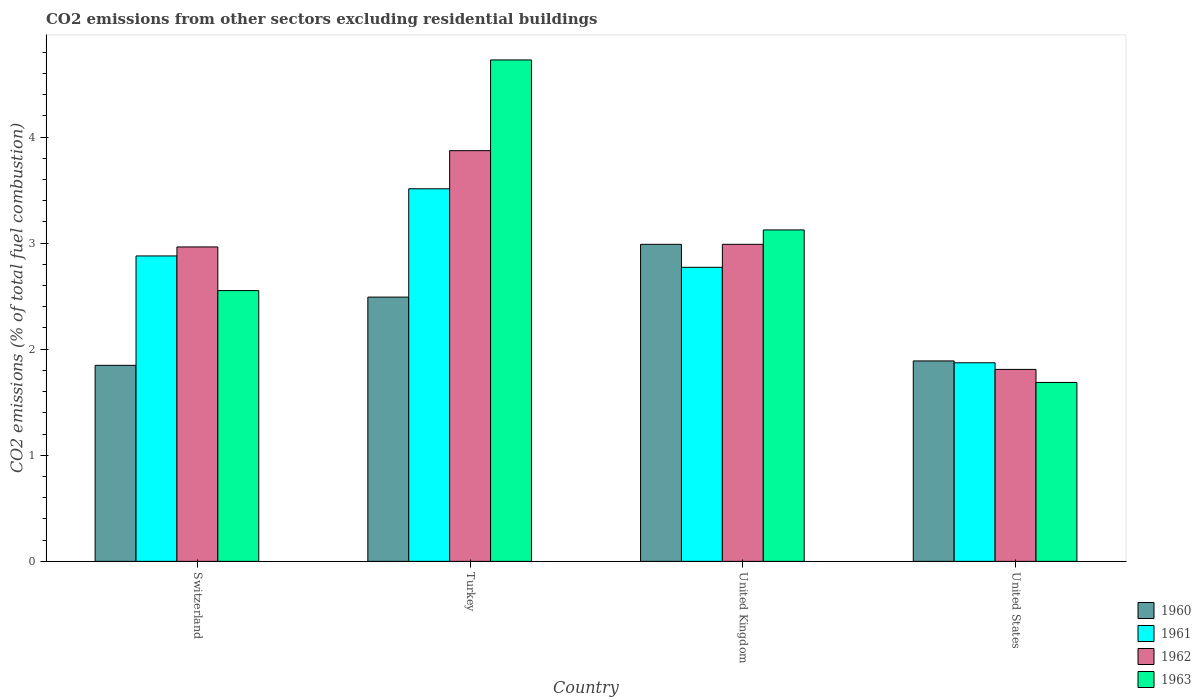How many different coloured bars are there?
Your response must be concise. 4. How many groups of bars are there?
Keep it short and to the point. 4. Are the number of bars per tick equal to the number of legend labels?
Ensure brevity in your answer.  Yes. Are the number of bars on each tick of the X-axis equal?
Keep it short and to the point. Yes. What is the label of the 2nd group of bars from the left?
Make the answer very short. Turkey. In how many cases, is the number of bars for a given country not equal to the number of legend labels?
Provide a short and direct response. 0. What is the total CO2 emitted in 1961 in Turkey?
Provide a short and direct response. 3.51. Across all countries, what is the maximum total CO2 emitted in 1963?
Your response must be concise. 4.73. Across all countries, what is the minimum total CO2 emitted in 1960?
Your answer should be compact. 1.85. In which country was the total CO2 emitted in 1961 maximum?
Keep it short and to the point. Turkey. In which country was the total CO2 emitted in 1962 minimum?
Ensure brevity in your answer.  United States. What is the total total CO2 emitted in 1961 in the graph?
Provide a succinct answer. 11.03. What is the difference between the total CO2 emitted in 1961 in Turkey and that in United Kingdom?
Provide a succinct answer. 0.74. What is the difference between the total CO2 emitted in 1960 in Turkey and the total CO2 emitted in 1963 in United Kingdom?
Offer a very short reply. -0.63. What is the average total CO2 emitted in 1963 per country?
Keep it short and to the point. 3.02. What is the difference between the total CO2 emitted of/in 1963 and total CO2 emitted of/in 1961 in United Kingdom?
Offer a very short reply. 0.35. In how many countries, is the total CO2 emitted in 1960 greater than 1.4?
Keep it short and to the point. 4. What is the ratio of the total CO2 emitted in 1961 in United Kingdom to that in United States?
Give a very brief answer. 1.48. Is the difference between the total CO2 emitted in 1963 in Turkey and United States greater than the difference between the total CO2 emitted in 1961 in Turkey and United States?
Make the answer very short. Yes. What is the difference between the highest and the second highest total CO2 emitted in 1961?
Your response must be concise. -0.63. What is the difference between the highest and the lowest total CO2 emitted in 1960?
Your answer should be compact. 1.14. Is it the case that in every country, the sum of the total CO2 emitted in 1960 and total CO2 emitted in 1961 is greater than the sum of total CO2 emitted in 1963 and total CO2 emitted in 1962?
Keep it short and to the point. No. What does the 1st bar from the left in United Kingdom represents?
Your answer should be very brief. 1960. Is it the case that in every country, the sum of the total CO2 emitted in 1963 and total CO2 emitted in 1962 is greater than the total CO2 emitted in 1961?
Provide a succinct answer. Yes. Are all the bars in the graph horizontal?
Give a very brief answer. No. How many countries are there in the graph?
Provide a succinct answer. 4. Are the values on the major ticks of Y-axis written in scientific E-notation?
Offer a terse response. No. Does the graph contain any zero values?
Make the answer very short. No. Where does the legend appear in the graph?
Your response must be concise. Bottom right. How many legend labels are there?
Offer a very short reply. 4. What is the title of the graph?
Your answer should be compact. CO2 emissions from other sectors excluding residential buildings. What is the label or title of the Y-axis?
Ensure brevity in your answer.  CO2 emissions (% of total fuel combustion). What is the CO2 emissions (% of total fuel combustion) of 1960 in Switzerland?
Make the answer very short. 1.85. What is the CO2 emissions (% of total fuel combustion) of 1961 in Switzerland?
Make the answer very short. 2.88. What is the CO2 emissions (% of total fuel combustion) of 1962 in Switzerland?
Make the answer very short. 2.96. What is the CO2 emissions (% of total fuel combustion) in 1963 in Switzerland?
Give a very brief answer. 2.55. What is the CO2 emissions (% of total fuel combustion) in 1960 in Turkey?
Offer a very short reply. 2.49. What is the CO2 emissions (% of total fuel combustion) in 1961 in Turkey?
Offer a very short reply. 3.51. What is the CO2 emissions (% of total fuel combustion) in 1962 in Turkey?
Your response must be concise. 3.87. What is the CO2 emissions (% of total fuel combustion) in 1963 in Turkey?
Ensure brevity in your answer.  4.73. What is the CO2 emissions (% of total fuel combustion) in 1960 in United Kingdom?
Ensure brevity in your answer.  2.99. What is the CO2 emissions (% of total fuel combustion) of 1961 in United Kingdom?
Keep it short and to the point. 2.77. What is the CO2 emissions (% of total fuel combustion) of 1962 in United Kingdom?
Make the answer very short. 2.99. What is the CO2 emissions (% of total fuel combustion) in 1963 in United Kingdom?
Ensure brevity in your answer.  3.12. What is the CO2 emissions (% of total fuel combustion) in 1960 in United States?
Your answer should be very brief. 1.89. What is the CO2 emissions (% of total fuel combustion) of 1961 in United States?
Keep it short and to the point. 1.87. What is the CO2 emissions (% of total fuel combustion) of 1962 in United States?
Your response must be concise. 1.81. What is the CO2 emissions (% of total fuel combustion) in 1963 in United States?
Offer a very short reply. 1.69. Across all countries, what is the maximum CO2 emissions (% of total fuel combustion) of 1960?
Ensure brevity in your answer.  2.99. Across all countries, what is the maximum CO2 emissions (% of total fuel combustion) of 1961?
Make the answer very short. 3.51. Across all countries, what is the maximum CO2 emissions (% of total fuel combustion) of 1962?
Keep it short and to the point. 3.87. Across all countries, what is the maximum CO2 emissions (% of total fuel combustion) in 1963?
Offer a very short reply. 4.73. Across all countries, what is the minimum CO2 emissions (% of total fuel combustion) in 1960?
Ensure brevity in your answer.  1.85. Across all countries, what is the minimum CO2 emissions (% of total fuel combustion) of 1961?
Provide a succinct answer. 1.87. Across all countries, what is the minimum CO2 emissions (% of total fuel combustion) in 1962?
Your answer should be compact. 1.81. Across all countries, what is the minimum CO2 emissions (% of total fuel combustion) in 1963?
Keep it short and to the point. 1.69. What is the total CO2 emissions (% of total fuel combustion) in 1960 in the graph?
Give a very brief answer. 9.22. What is the total CO2 emissions (% of total fuel combustion) in 1961 in the graph?
Make the answer very short. 11.03. What is the total CO2 emissions (% of total fuel combustion) in 1962 in the graph?
Offer a very short reply. 11.63. What is the total CO2 emissions (% of total fuel combustion) of 1963 in the graph?
Make the answer very short. 12.09. What is the difference between the CO2 emissions (% of total fuel combustion) of 1960 in Switzerland and that in Turkey?
Make the answer very short. -0.64. What is the difference between the CO2 emissions (% of total fuel combustion) in 1961 in Switzerland and that in Turkey?
Provide a succinct answer. -0.63. What is the difference between the CO2 emissions (% of total fuel combustion) of 1962 in Switzerland and that in Turkey?
Provide a short and direct response. -0.91. What is the difference between the CO2 emissions (% of total fuel combustion) of 1963 in Switzerland and that in Turkey?
Ensure brevity in your answer.  -2.17. What is the difference between the CO2 emissions (% of total fuel combustion) in 1960 in Switzerland and that in United Kingdom?
Keep it short and to the point. -1.14. What is the difference between the CO2 emissions (% of total fuel combustion) of 1961 in Switzerland and that in United Kingdom?
Your answer should be compact. 0.11. What is the difference between the CO2 emissions (% of total fuel combustion) in 1962 in Switzerland and that in United Kingdom?
Give a very brief answer. -0.02. What is the difference between the CO2 emissions (% of total fuel combustion) of 1963 in Switzerland and that in United Kingdom?
Give a very brief answer. -0.57. What is the difference between the CO2 emissions (% of total fuel combustion) of 1960 in Switzerland and that in United States?
Offer a very short reply. -0.04. What is the difference between the CO2 emissions (% of total fuel combustion) in 1961 in Switzerland and that in United States?
Provide a succinct answer. 1.01. What is the difference between the CO2 emissions (% of total fuel combustion) in 1962 in Switzerland and that in United States?
Offer a terse response. 1.15. What is the difference between the CO2 emissions (% of total fuel combustion) of 1963 in Switzerland and that in United States?
Provide a succinct answer. 0.87. What is the difference between the CO2 emissions (% of total fuel combustion) of 1960 in Turkey and that in United Kingdom?
Provide a succinct answer. -0.5. What is the difference between the CO2 emissions (% of total fuel combustion) of 1961 in Turkey and that in United Kingdom?
Provide a short and direct response. 0.74. What is the difference between the CO2 emissions (% of total fuel combustion) in 1962 in Turkey and that in United Kingdom?
Offer a terse response. 0.88. What is the difference between the CO2 emissions (% of total fuel combustion) in 1963 in Turkey and that in United Kingdom?
Your answer should be very brief. 1.6. What is the difference between the CO2 emissions (% of total fuel combustion) in 1960 in Turkey and that in United States?
Offer a terse response. 0.6. What is the difference between the CO2 emissions (% of total fuel combustion) in 1961 in Turkey and that in United States?
Make the answer very short. 1.64. What is the difference between the CO2 emissions (% of total fuel combustion) in 1962 in Turkey and that in United States?
Your response must be concise. 2.06. What is the difference between the CO2 emissions (% of total fuel combustion) of 1963 in Turkey and that in United States?
Make the answer very short. 3.04. What is the difference between the CO2 emissions (% of total fuel combustion) in 1960 in United Kingdom and that in United States?
Your response must be concise. 1.1. What is the difference between the CO2 emissions (% of total fuel combustion) of 1961 in United Kingdom and that in United States?
Your answer should be very brief. 0.9. What is the difference between the CO2 emissions (% of total fuel combustion) of 1962 in United Kingdom and that in United States?
Make the answer very short. 1.18. What is the difference between the CO2 emissions (% of total fuel combustion) in 1963 in United Kingdom and that in United States?
Your response must be concise. 1.44. What is the difference between the CO2 emissions (% of total fuel combustion) in 1960 in Switzerland and the CO2 emissions (% of total fuel combustion) in 1961 in Turkey?
Provide a short and direct response. -1.66. What is the difference between the CO2 emissions (% of total fuel combustion) of 1960 in Switzerland and the CO2 emissions (% of total fuel combustion) of 1962 in Turkey?
Offer a very short reply. -2.02. What is the difference between the CO2 emissions (% of total fuel combustion) of 1960 in Switzerland and the CO2 emissions (% of total fuel combustion) of 1963 in Turkey?
Your answer should be very brief. -2.88. What is the difference between the CO2 emissions (% of total fuel combustion) of 1961 in Switzerland and the CO2 emissions (% of total fuel combustion) of 1962 in Turkey?
Offer a terse response. -0.99. What is the difference between the CO2 emissions (% of total fuel combustion) of 1961 in Switzerland and the CO2 emissions (% of total fuel combustion) of 1963 in Turkey?
Provide a succinct answer. -1.85. What is the difference between the CO2 emissions (% of total fuel combustion) in 1962 in Switzerland and the CO2 emissions (% of total fuel combustion) in 1963 in Turkey?
Make the answer very short. -1.76. What is the difference between the CO2 emissions (% of total fuel combustion) of 1960 in Switzerland and the CO2 emissions (% of total fuel combustion) of 1961 in United Kingdom?
Provide a succinct answer. -0.92. What is the difference between the CO2 emissions (% of total fuel combustion) of 1960 in Switzerland and the CO2 emissions (% of total fuel combustion) of 1962 in United Kingdom?
Your response must be concise. -1.14. What is the difference between the CO2 emissions (% of total fuel combustion) in 1960 in Switzerland and the CO2 emissions (% of total fuel combustion) in 1963 in United Kingdom?
Your answer should be compact. -1.28. What is the difference between the CO2 emissions (% of total fuel combustion) of 1961 in Switzerland and the CO2 emissions (% of total fuel combustion) of 1962 in United Kingdom?
Keep it short and to the point. -0.11. What is the difference between the CO2 emissions (% of total fuel combustion) of 1961 in Switzerland and the CO2 emissions (% of total fuel combustion) of 1963 in United Kingdom?
Ensure brevity in your answer.  -0.25. What is the difference between the CO2 emissions (% of total fuel combustion) of 1962 in Switzerland and the CO2 emissions (% of total fuel combustion) of 1963 in United Kingdom?
Provide a succinct answer. -0.16. What is the difference between the CO2 emissions (% of total fuel combustion) of 1960 in Switzerland and the CO2 emissions (% of total fuel combustion) of 1961 in United States?
Offer a very short reply. -0.02. What is the difference between the CO2 emissions (% of total fuel combustion) of 1960 in Switzerland and the CO2 emissions (% of total fuel combustion) of 1962 in United States?
Offer a terse response. 0.04. What is the difference between the CO2 emissions (% of total fuel combustion) of 1960 in Switzerland and the CO2 emissions (% of total fuel combustion) of 1963 in United States?
Provide a short and direct response. 0.16. What is the difference between the CO2 emissions (% of total fuel combustion) in 1961 in Switzerland and the CO2 emissions (% of total fuel combustion) in 1962 in United States?
Provide a short and direct response. 1.07. What is the difference between the CO2 emissions (% of total fuel combustion) in 1961 in Switzerland and the CO2 emissions (% of total fuel combustion) in 1963 in United States?
Provide a succinct answer. 1.19. What is the difference between the CO2 emissions (% of total fuel combustion) in 1962 in Switzerland and the CO2 emissions (% of total fuel combustion) in 1963 in United States?
Give a very brief answer. 1.28. What is the difference between the CO2 emissions (% of total fuel combustion) of 1960 in Turkey and the CO2 emissions (% of total fuel combustion) of 1961 in United Kingdom?
Provide a succinct answer. -0.28. What is the difference between the CO2 emissions (% of total fuel combustion) of 1960 in Turkey and the CO2 emissions (% of total fuel combustion) of 1962 in United Kingdom?
Your answer should be very brief. -0.5. What is the difference between the CO2 emissions (% of total fuel combustion) of 1960 in Turkey and the CO2 emissions (% of total fuel combustion) of 1963 in United Kingdom?
Your response must be concise. -0.63. What is the difference between the CO2 emissions (% of total fuel combustion) of 1961 in Turkey and the CO2 emissions (% of total fuel combustion) of 1962 in United Kingdom?
Offer a terse response. 0.52. What is the difference between the CO2 emissions (% of total fuel combustion) in 1961 in Turkey and the CO2 emissions (% of total fuel combustion) in 1963 in United Kingdom?
Make the answer very short. 0.39. What is the difference between the CO2 emissions (% of total fuel combustion) in 1962 in Turkey and the CO2 emissions (% of total fuel combustion) in 1963 in United Kingdom?
Your answer should be compact. 0.75. What is the difference between the CO2 emissions (% of total fuel combustion) in 1960 in Turkey and the CO2 emissions (% of total fuel combustion) in 1961 in United States?
Your response must be concise. 0.62. What is the difference between the CO2 emissions (% of total fuel combustion) in 1960 in Turkey and the CO2 emissions (% of total fuel combustion) in 1962 in United States?
Make the answer very short. 0.68. What is the difference between the CO2 emissions (% of total fuel combustion) of 1960 in Turkey and the CO2 emissions (% of total fuel combustion) of 1963 in United States?
Ensure brevity in your answer.  0.8. What is the difference between the CO2 emissions (% of total fuel combustion) in 1961 in Turkey and the CO2 emissions (% of total fuel combustion) in 1962 in United States?
Make the answer very short. 1.7. What is the difference between the CO2 emissions (% of total fuel combustion) of 1961 in Turkey and the CO2 emissions (% of total fuel combustion) of 1963 in United States?
Your answer should be very brief. 1.83. What is the difference between the CO2 emissions (% of total fuel combustion) of 1962 in Turkey and the CO2 emissions (% of total fuel combustion) of 1963 in United States?
Give a very brief answer. 2.18. What is the difference between the CO2 emissions (% of total fuel combustion) of 1960 in United Kingdom and the CO2 emissions (% of total fuel combustion) of 1961 in United States?
Your response must be concise. 1.12. What is the difference between the CO2 emissions (% of total fuel combustion) of 1960 in United Kingdom and the CO2 emissions (% of total fuel combustion) of 1962 in United States?
Provide a short and direct response. 1.18. What is the difference between the CO2 emissions (% of total fuel combustion) in 1960 in United Kingdom and the CO2 emissions (% of total fuel combustion) in 1963 in United States?
Offer a terse response. 1.3. What is the difference between the CO2 emissions (% of total fuel combustion) in 1961 in United Kingdom and the CO2 emissions (% of total fuel combustion) in 1962 in United States?
Offer a very short reply. 0.96. What is the difference between the CO2 emissions (% of total fuel combustion) in 1961 in United Kingdom and the CO2 emissions (% of total fuel combustion) in 1963 in United States?
Your answer should be very brief. 1.09. What is the difference between the CO2 emissions (% of total fuel combustion) in 1962 in United Kingdom and the CO2 emissions (% of total fuel combustion) in 1963 in United States?
Your answer should be compact. 1.3. What is the average CO2 emissions (% of total fuel combustion) of 1960 per country?
Keep it short and to the point. 2.3. What is the average CO2 emissions (% of total fuel combustion) of 1961 per country?
Provide a succinct answer. 2.76. What is the average CO2 emissions (% of total fuel combustion) of 1962 per country?
Offer a very short reply. 2.91. What is the average CO2 emissions (% of total fuel combustion) in 1963 per country?
Provide a succinct answer. 3.02. What is the difference between the CO2 emissions (% of total fuel combustion) of 1960 and CO2 emissions (% of total fuel combustion) of 1961 in Switzerland?
Provide a short and direct response. -1.03. What is the difference between the CO2 emissions (% of total fuel combustion) in 1960 and CO2 emissions (% of total fuel combustion) in 1962 in Switzerland?
Make the answer very short. -1.12. What is the difference between the CO2 emissions (% of total fuel combustion) of 1960 and CO2 emissions (% of total fuel combustion) of 1963 in Switzerland?
Your answer should be compact. -0.7. What is the difference between the CO2 emissions (% of total fuel combustion) in 1961 and CO2 emissions (% of total fuel combustion) in 1962 in Switzerland?
Your response must be concise. -0.08. What is the difference between the CO2 emissions (% of total fuel combustion) in 1961 and CO2 emissions (% of total fuel combustion) in 1963 in Switzerland?
Your answer should be very brief. 0.33. What is the difference between the CO2 emissions (% of total fuel combustion) in 1962 and CO2 emissions (% of total fuel combustion) in 1963 in Switzerland?
Provide a succinct answer. 0.41. What is the difference between the CO2 emissions (% of total fuel combustion) in 1960 and CO2 emissions (% of total fuel combustion) in 1961 in Turkey?
Your answer should be compact. -1.02. What is the difference between the CO2 emissions (% of total fuel combustion) of 1960 and CO2 emissions (% of total fuel combustion) of 1962 in Turkey?
Make the answer very short. -1.38. What is the difference between the CO2 emissions (% of total fuel combustion) in 1960 and CO2 emissions (% of total fuel combustion) in 1963 in Turkey?
Your answer should be compact. -2.24. What is the difference between the CO2 emissions (% of total fuel combustion) in 1961 and CO2 emissions (% of total fuel combustion) in 1962 in Turkey?
Offer a terse response. -0.36. What is the difference between the CO2 emissions (% of total fuel combustion) in 1961 and CO2 emissions (% of total fuel combustion) in 1963 in Turkey?
Provide a short and direct response. -1.21. What is the difference between the CO2 emissions (% of total fuel combustion) of 1962 and CO2 emissions (% of total fuel combustion) of 1963 in Turkey?
Keep it short and to the point. -0.85. What is the difference between the CO2 emissions (% of total fuel combustion) in 1960 and CO2 emissions (% of total fuel combustion) in 1961 in United Kingdom?
Ensure brevity in your answer.  0.22. What is the difference between the CO2 emissions (% of total fuel combustion) in 1960 and CO2 emissions (% of total fuel combustion) in 1963 in United Kingdom?
Make the answer very short. -0.14. What is the difference between the CO2 emissions (% of total fuel combustion) in 1961 and CO2 emissions (% of total fuel combustion) in 1962 in United Kingdom?
Provide a succinct answer. -0.22. What is the difference between the CO2 emissions (% of total fuel combustion) in 1961 and CO2 emissions (% of total fuel combustion) in 1963 in United Kingdom?
Your response must be concise. -0.35. What is the difference between the CO2 emissions (% of total fuel combustion) in 1962 and CO2 emissions (% of total fuel combustion) in 1963 in United Kingdom?
Keep it short and to the point. -0.14. What is the difference between the CO2 emissions (% of total fuel combustion) in 1960 and CO2 emissions (% of total fuel combustion) in 1961 in United States?
Keep it short and to the point. 0.02. What is the difference between the CO2 emissions (% of total fuel combustion) of 1960 and CO2 emissions (% of total fuel combustion) of 1962 in United States?
Your answer should be compact. 0.08. What is the difference between the CO2 emissions (% of total fuel combustion) of 1960 and CO2 emissions (% of total fuel combustion) of 1963 in United States?
Offer a terse response. 0.2. What is the difference between the CO2 emissions (% of total fuel combustion) of 1961 and CO2 emissions (% of total fuel combustion) of 1962 in United States?
Your answer should be very brief. 0.06. What is the difference between the CO2 emissions (% of total fuel combustion) in 1961 and CO2 emissions (% of total fuel combustion) in 1963 in United States?
Give a very brief answer. 0.19. What is the difference between the CO2 emissions (% of total fuel combustion) in 1962 and CO2 emissions (% of total fuel combustion) in 1963 in United States?
Your answer should be compact. 0.12. What is the ratio of the CO2 emissions (% of total fuel combustion) of 1960 in Switzerland to that in Turkey?
Ensure brevity in your answer.  0.74. What is the ratio of the CO2 emissions (% of total fuel combustion) in 1961 in Switzerland to that in Turkey?
Your response must be concise. 0.82. What is the ratio of the CO2 emissions (% of total fuel combustion) in 1962 in Switzerland to that in Turkey?
Make the answer very short. 0.77. What is the ratio of the CO2 emissions (% of total fuel combustion) in 1963 in Switzerland to that in Turkey?
Make the answer very short. 0.54. What is the ratio of the CO2 emissions (% of total fuel combustion) in 1960 in Switzerland to that in United Kingdom?
Ensure brevity in your answer.  0.62. What is the ratio of the CO2 emissions (% of total fuel combustion) of 1961 in Switzerland to that in United Kingdom?
Offer a terse response. 1.04. What is the ratio of the CO2 emissions (% of total fuel combustion) of 1963 in Switzerland to that in United Kingdom?
Make the answer very short. 0.82. What is the ratio of the CO2 emissions (% of total fuel combustion) of 1961 in Switzerland to that in United States?
Ensure brevity in your answer.  1.54. What is the ratio of the CO2 emissions (% of total fuel combustion) in 1962 in Switzerland to that in United States?
Keep it short and to the point. 1.64. What is the ratio of the CO2 emissions (% of total fuel combustion) of 1963 in Switzerland to that in United States?
Your answer should be very brief. 1.51. What is the ratio of the CO2 emissions (% of total fuel combustion) of 1960 in Turkey to that in United Kingdom?
Keep it short and to the point. 0.83. What is the ratio of the CO2 emissions (% of total fuel combustion) in 1961 in Turkey to that in United Kingdom?
Your answer should be very brief. 1.27. What is the ratio of the CO2 emissions (% of total fuel combustion) in 1962 in Turkey to that in United Kingdom?
Offer a terse response. 1.3. What is the ratio of the CO2 emissions (% of total fuel combustion) of 1963 in Turkey to that in United Kingdom?
Your response must be concise. 1.51. What is the ratio of the CO2 emissions (% of total fuel combustion) of 1960 in Turkey to that in United States?
Your answer should be compact. 1.32. What is the ratio of the CO2 emissions (% of total fuel combustion) of 1961 in Turkey to that in United States?
Your answer should be very brief. 1.88. What is the ratio of the CO2 emissions (% of total fuel combustion) in 1962 in Turkey to that in United States?
Offer a terse response. 2.14. What is the ratio of the CO2 emissions (% of total fuel combustion) in 1963 in Turkey to that in United States?
Your answer should be very brief. 2.8. What is the ratio of the CO2 emissions (% of total fuel combustion) of 1960 in United Kingdom to that in United States?
Ensure brevity in your answer.  1.58. What is the ratio of the CO2 emissions (% of total fuel combustion) of 1961 in United Kingdom to that in United States?
Ensure brevity in your answer.  1.48. What is the ratio of the CO2 emissions (% of total fuel combustion) of 1962 in United Kingdom to that in United States?
Provide a short and direct response. 1.65. What is the ratio of the CO2 emissions (% of total fuel combustion) of 1963 in United Kingdom to that in United States?
Give a very brief answer. 1.85. What is the difference between the highest and the second highest CO2 emissions (% of total fuel combustion) in 1960?
Your response must be concise. 0.5. What is the difference between the highest and the second highest CO2 emissions (% of total fuel combustion) of 1961?
Provide a short and direct response. 0.63. What is the difference between the highest and the second highest CO2 emissions (% of total fuel combustion) in 1962?
Keep it short and to the point. 0.88. What is the difference between the highest and the second highest CO2 emissions (% of total fuel combustion) of 1963?
Make the answer very short. 1.6. What is the difference between the highest and the lowest CO2 emissions (% of total fuel combustion) in 1960?
Keep it short and to the point. 1.14. What is the difference between the highest and the lowest CO2 emissions (% of total fuel combustion) in 1961?
Ensure brevity in your answer.  1.64. What is the difference between the highest and the lowest CO2 emissions (% of total fuel combustion) of 1962?
Ensure brevity in your answer.  2.06. What is the difference between the highest and the lowest CO2 emissions (% of total fuel combustion) of 1963?
Your answer should be very brief. 3.04. 